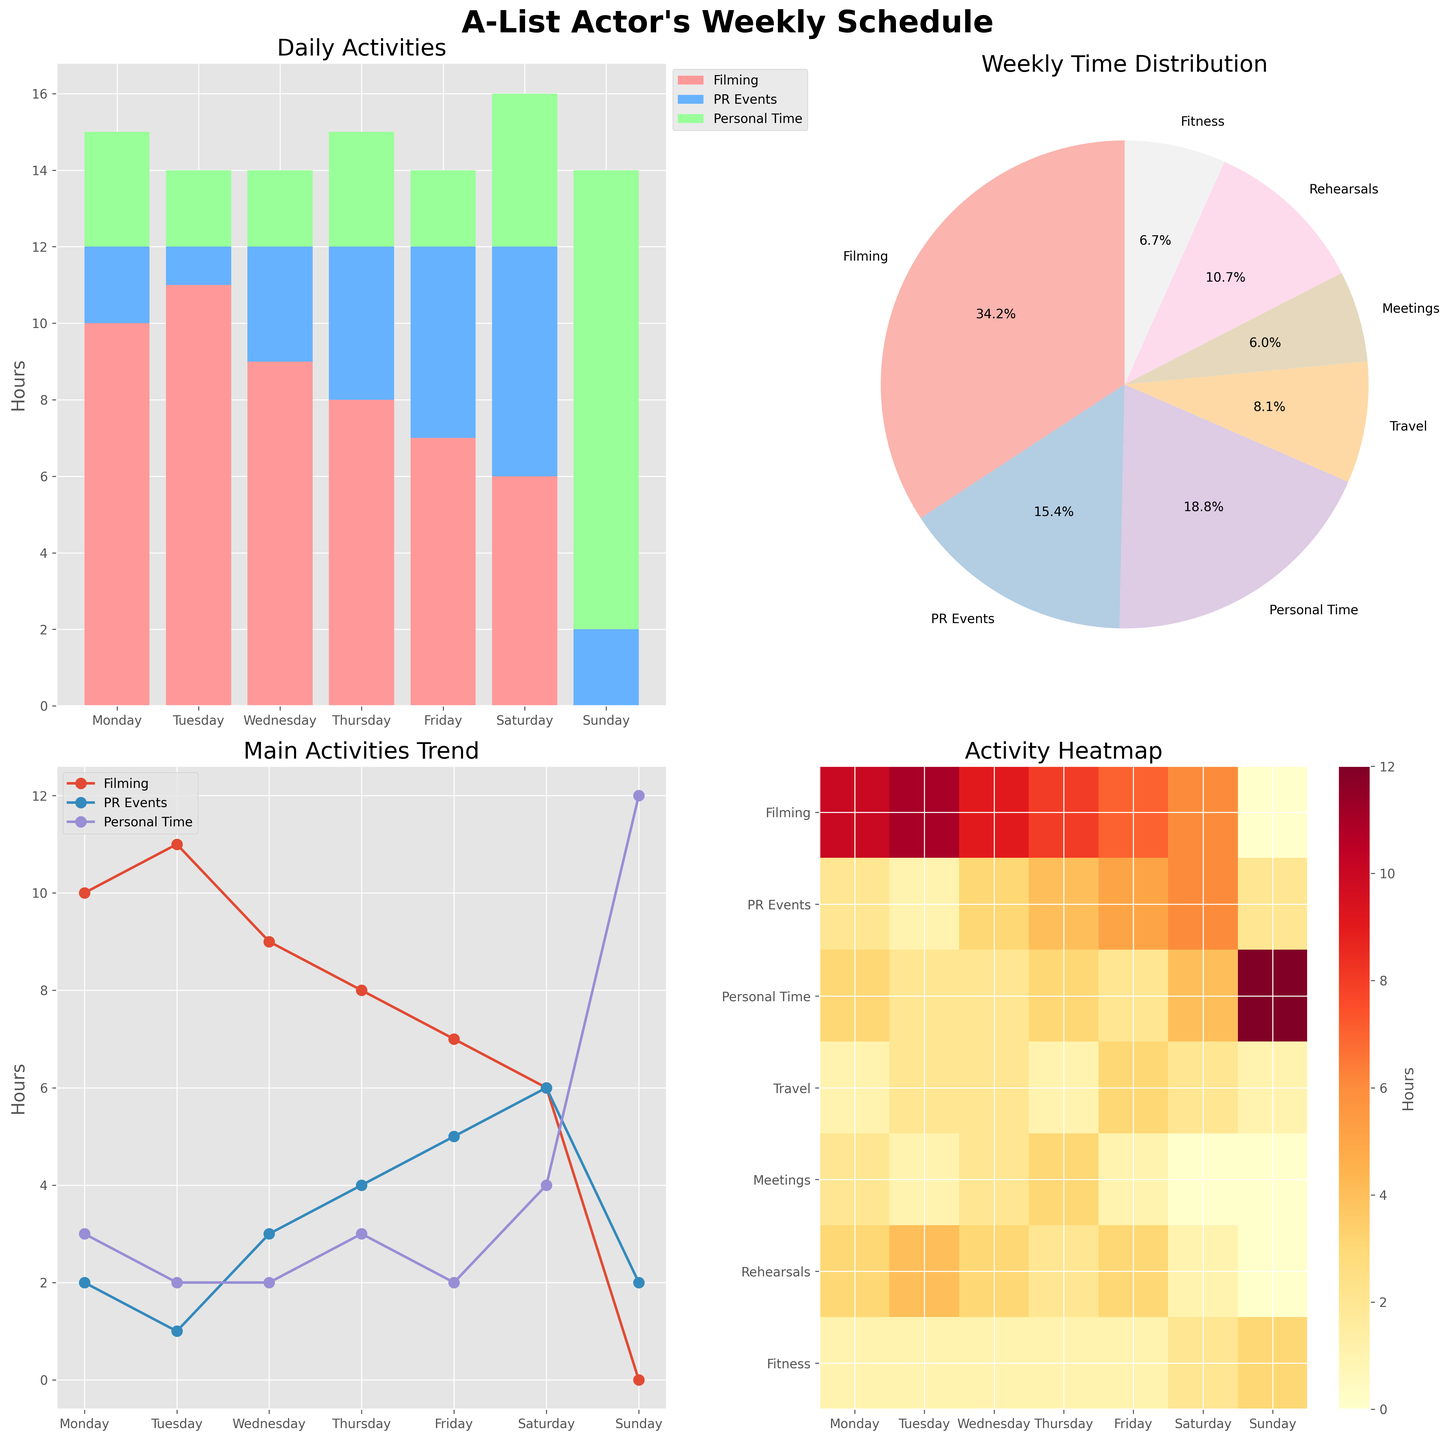What activity does the actor spend the most time on during the week? In the pie chart titled "Weekly Time Distribution," observe the activity with the largest slice. Filming has 51 hours, which is the majority compared to other activities.
Answer: Filming Which day has the actor allocated the most time to PR Events? Look at the stacked bar chart "Daily Activities." Find the tallest segment for the 'PR Events' color (light blue). Thursday and Friday appear to be the most. Check the values on Friday, which appear to total 5 hours. This is more compared to other days.
Answer: Friday What is the sum of hours spent on Personal Time and Fitness on Sunday? Refer to the line plot titled "Main Activities Trend" for Personal Time on Sunday, which peaks at 12 hours. For Fitness, check the stacked bar chart where Sunday has a segment of 3 hours. Adding these together, 12 + 3 = 15 hours.
Answer: 15 hours On which day is the cumulative time for Filming, Meetings, and Fitness the least? Check the heatmap for the days with the least combined intensity for these activities. On Sunday, Filming is 0, Meetings is 0, and Fitness is 3. Sum them to get 3 hours which is the lowest in comparison to other days.
Answer: Sunday Compare Monday and Wednesday, which day has more hours allocated to Meetings? From the heatmap or the stacked bar chart, you can see that Monday has 2 hours allocated, while Wednesday has 2 hours. Hence, both days have equal hours for Meetings.
Answer: Equal Which activity does the actor spend the least cumulative time on during the week? The pie chart shows the total time distribution for all activities. The smallest slice corresponds to Meetings, at 9 hours.
Answer: Meetings How does the trend for Filming hours change from Monday to Saturday? Refer to the line plot "Main Activities Trend." Start from Monday (10 hours), then observe a decrease through the week—Tuesday (11), Wednesday (9), Thursday (8), Friday (7), and finally Saturday (6). There's a downward trend.
Answer: Decreasing What is the difference in hours allocated to PR Events between Thursday and Tuesday? On the stacked bar chart, Thursday shows 4 hours, and Tuesday shows 1 hour for PR Events. Calculate the difference, which is 4 - 1 = 3 hours.
Answer: 3 hours Explain the change in Personal Time from Friday to Saturday. Using the line plot, Personal Time is stable at 2 hours from Monday to Friday, then it jumps to 4 hours on Saturday. The change is an increase  by 4 - 2 = 2 hours.
Answer: Increase by 2 hours 